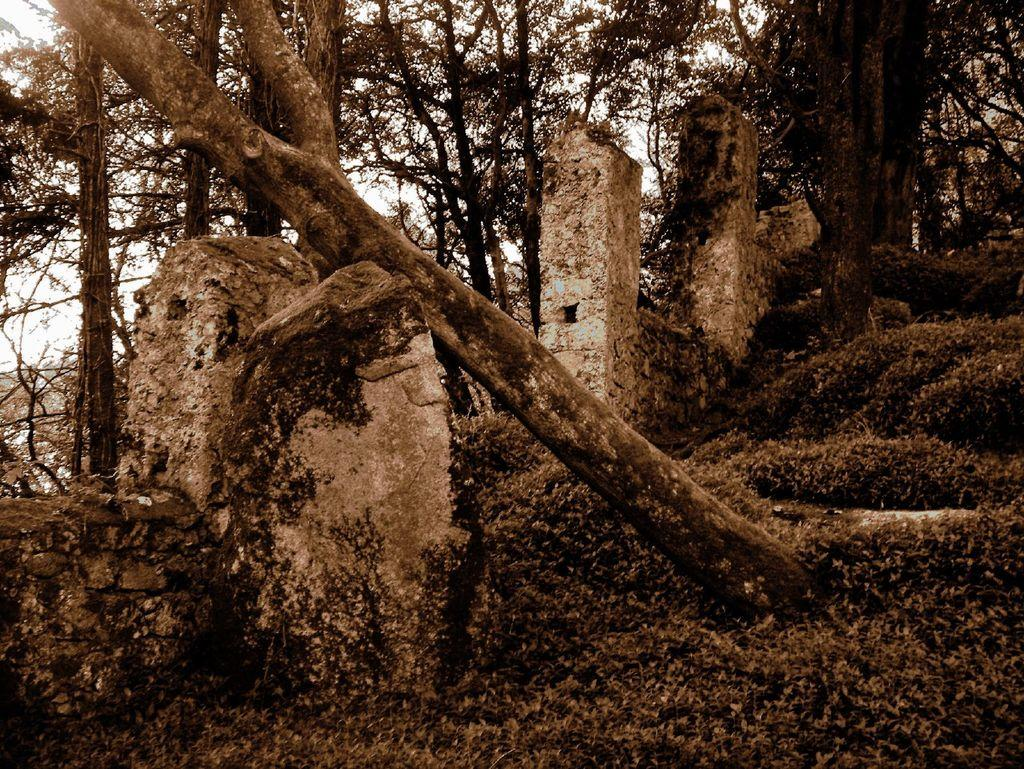What type of natural elements can be seen in the image? There are stones and trees in the image. What is the color of the background in the image? The background of the image is white. Can you see a goat playing a guitar in the image? No, there is no goat or guitar present in the image. What type of spark can be seen coming from the trees in the image? There is no spark visible in the image; it only features stones and trees against a white background. 